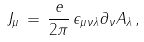Convert formula to latex. <formula><loc_0><loc_0><loc_500><loc_500>J _ { \mu } \, = \, \frac { e } { 2 \pi } \, \epsilon _ { \mu \nu \lambda } \partial _ { \nu } A _ { \lambda } \, ,</formula> 